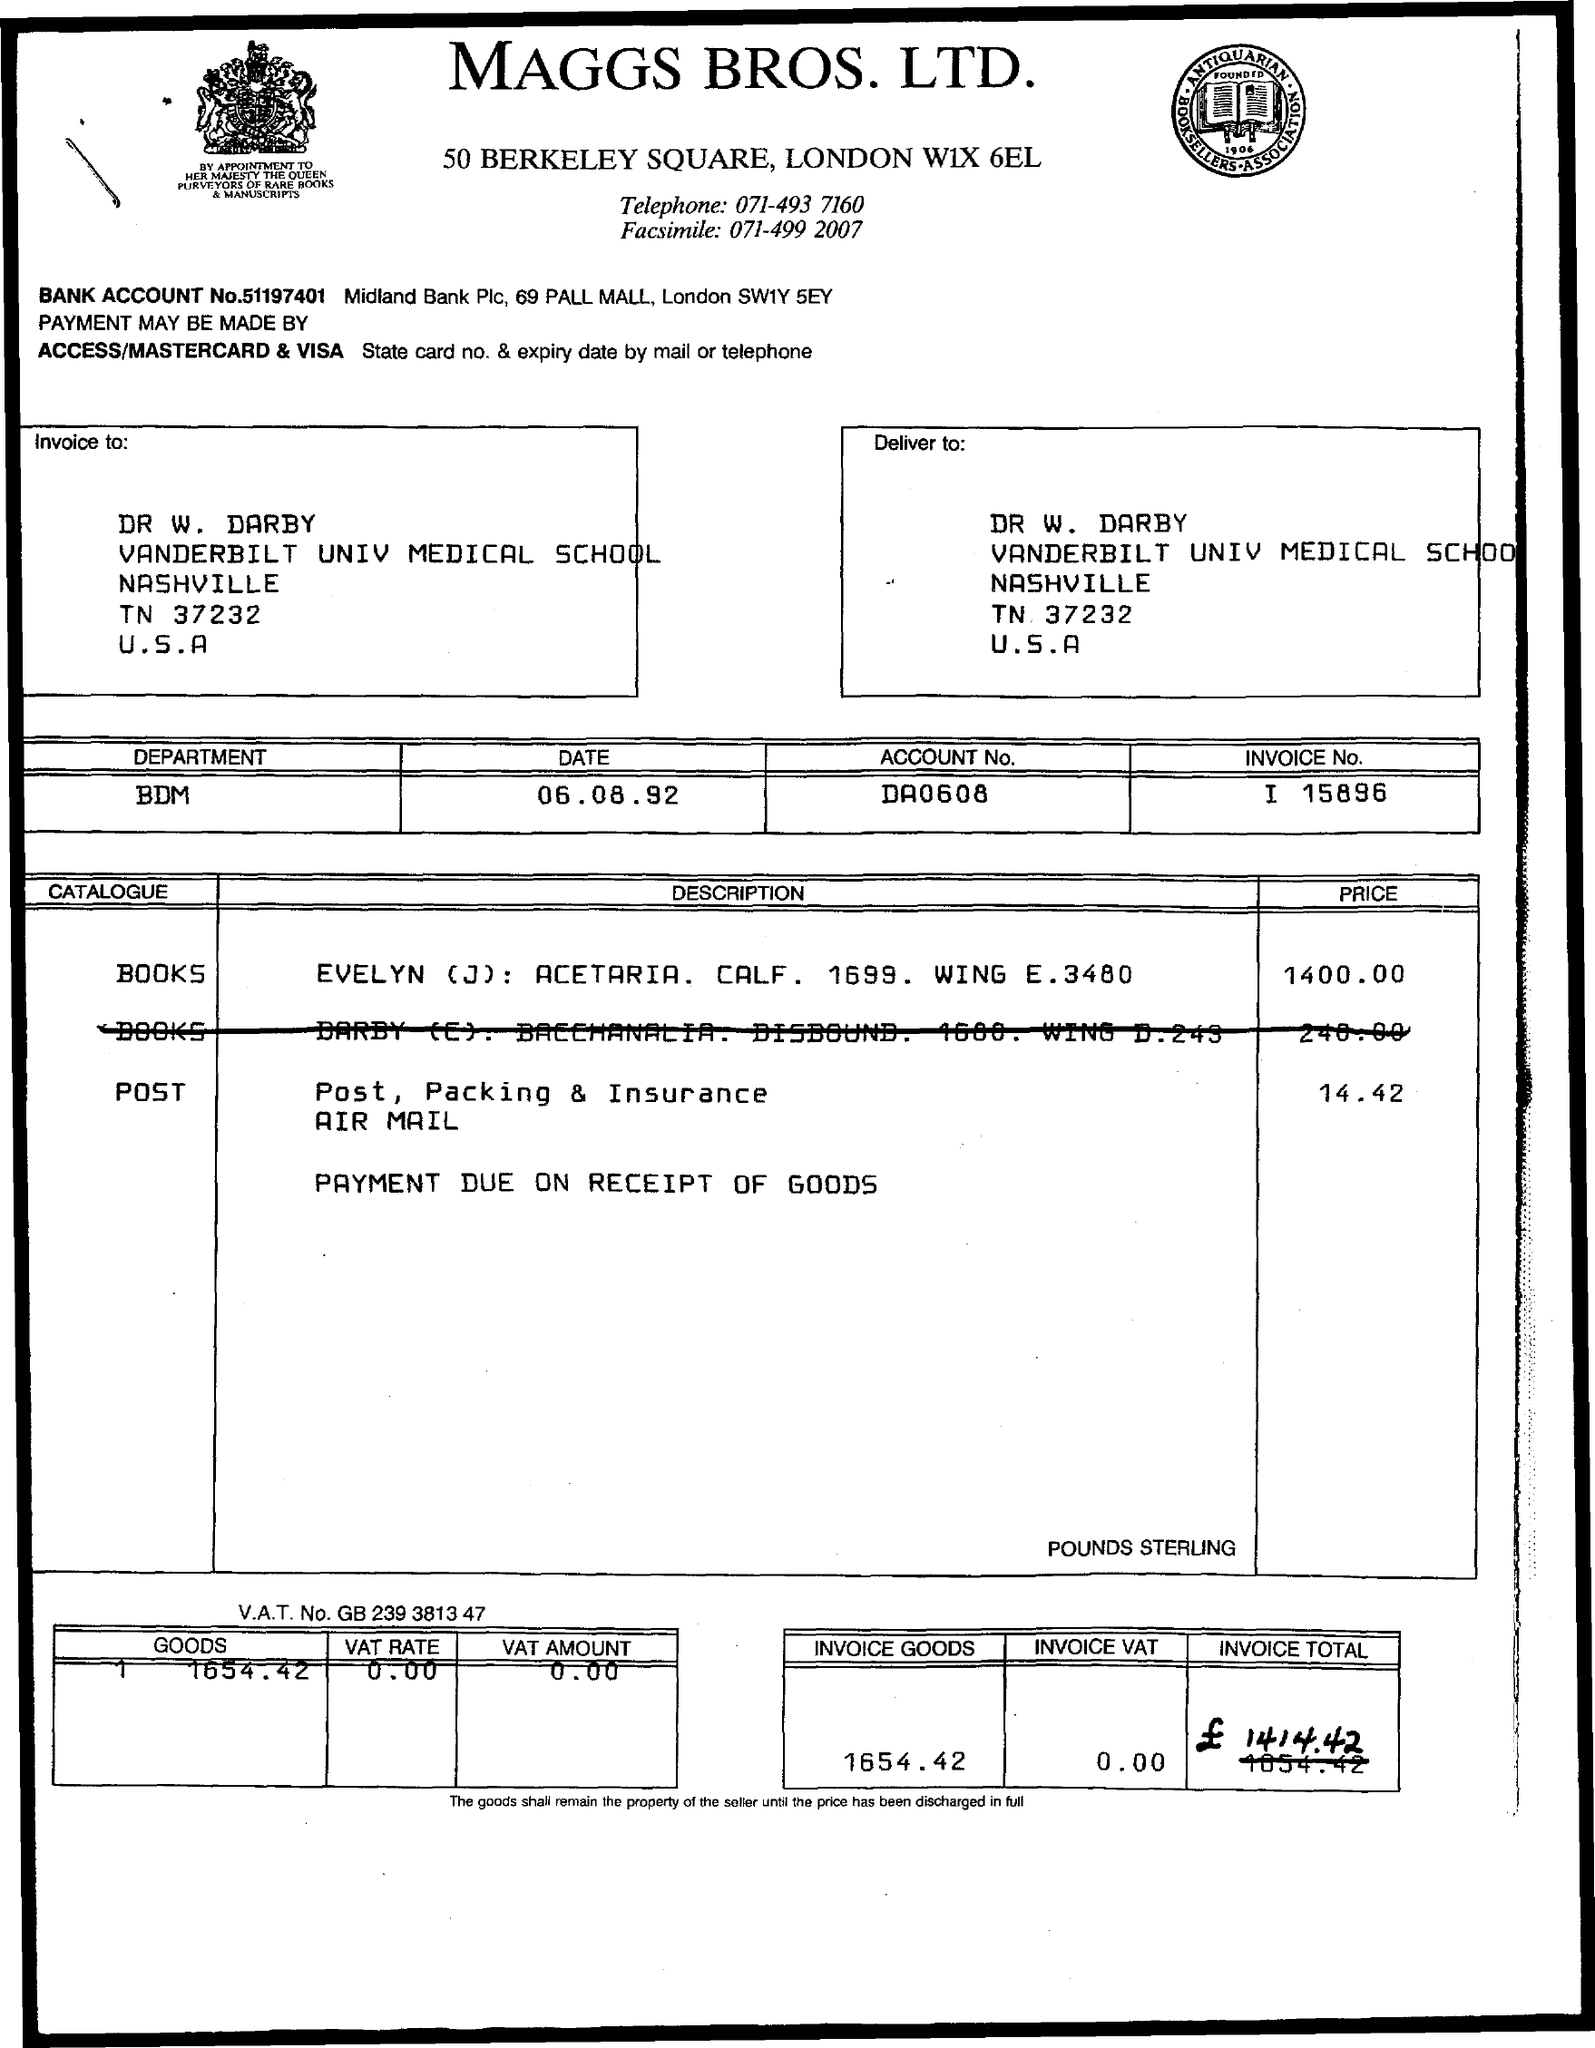What is the VAT rate applied to the goods? The VAT rate applied to the goods on this invoice is 0%, as indicated by the VAT amount of £0.00. 